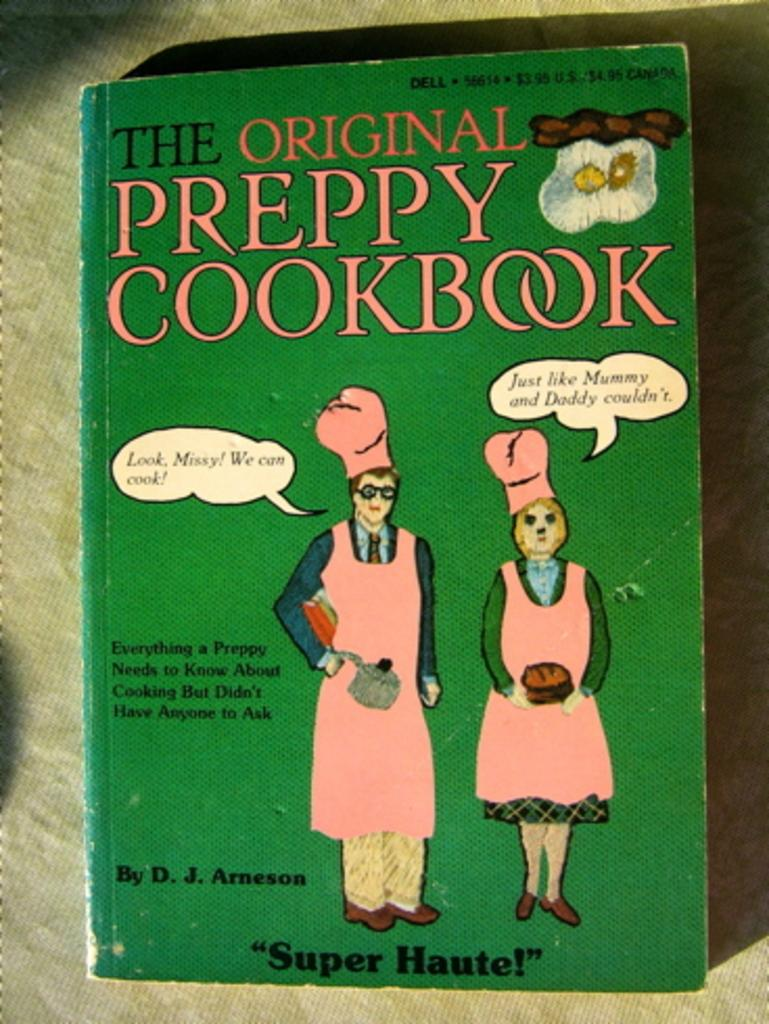<image>
Render a clear and concise summary of the photo. the book The original Preppy cookbook has a man and woman on it wearing pink aprons 